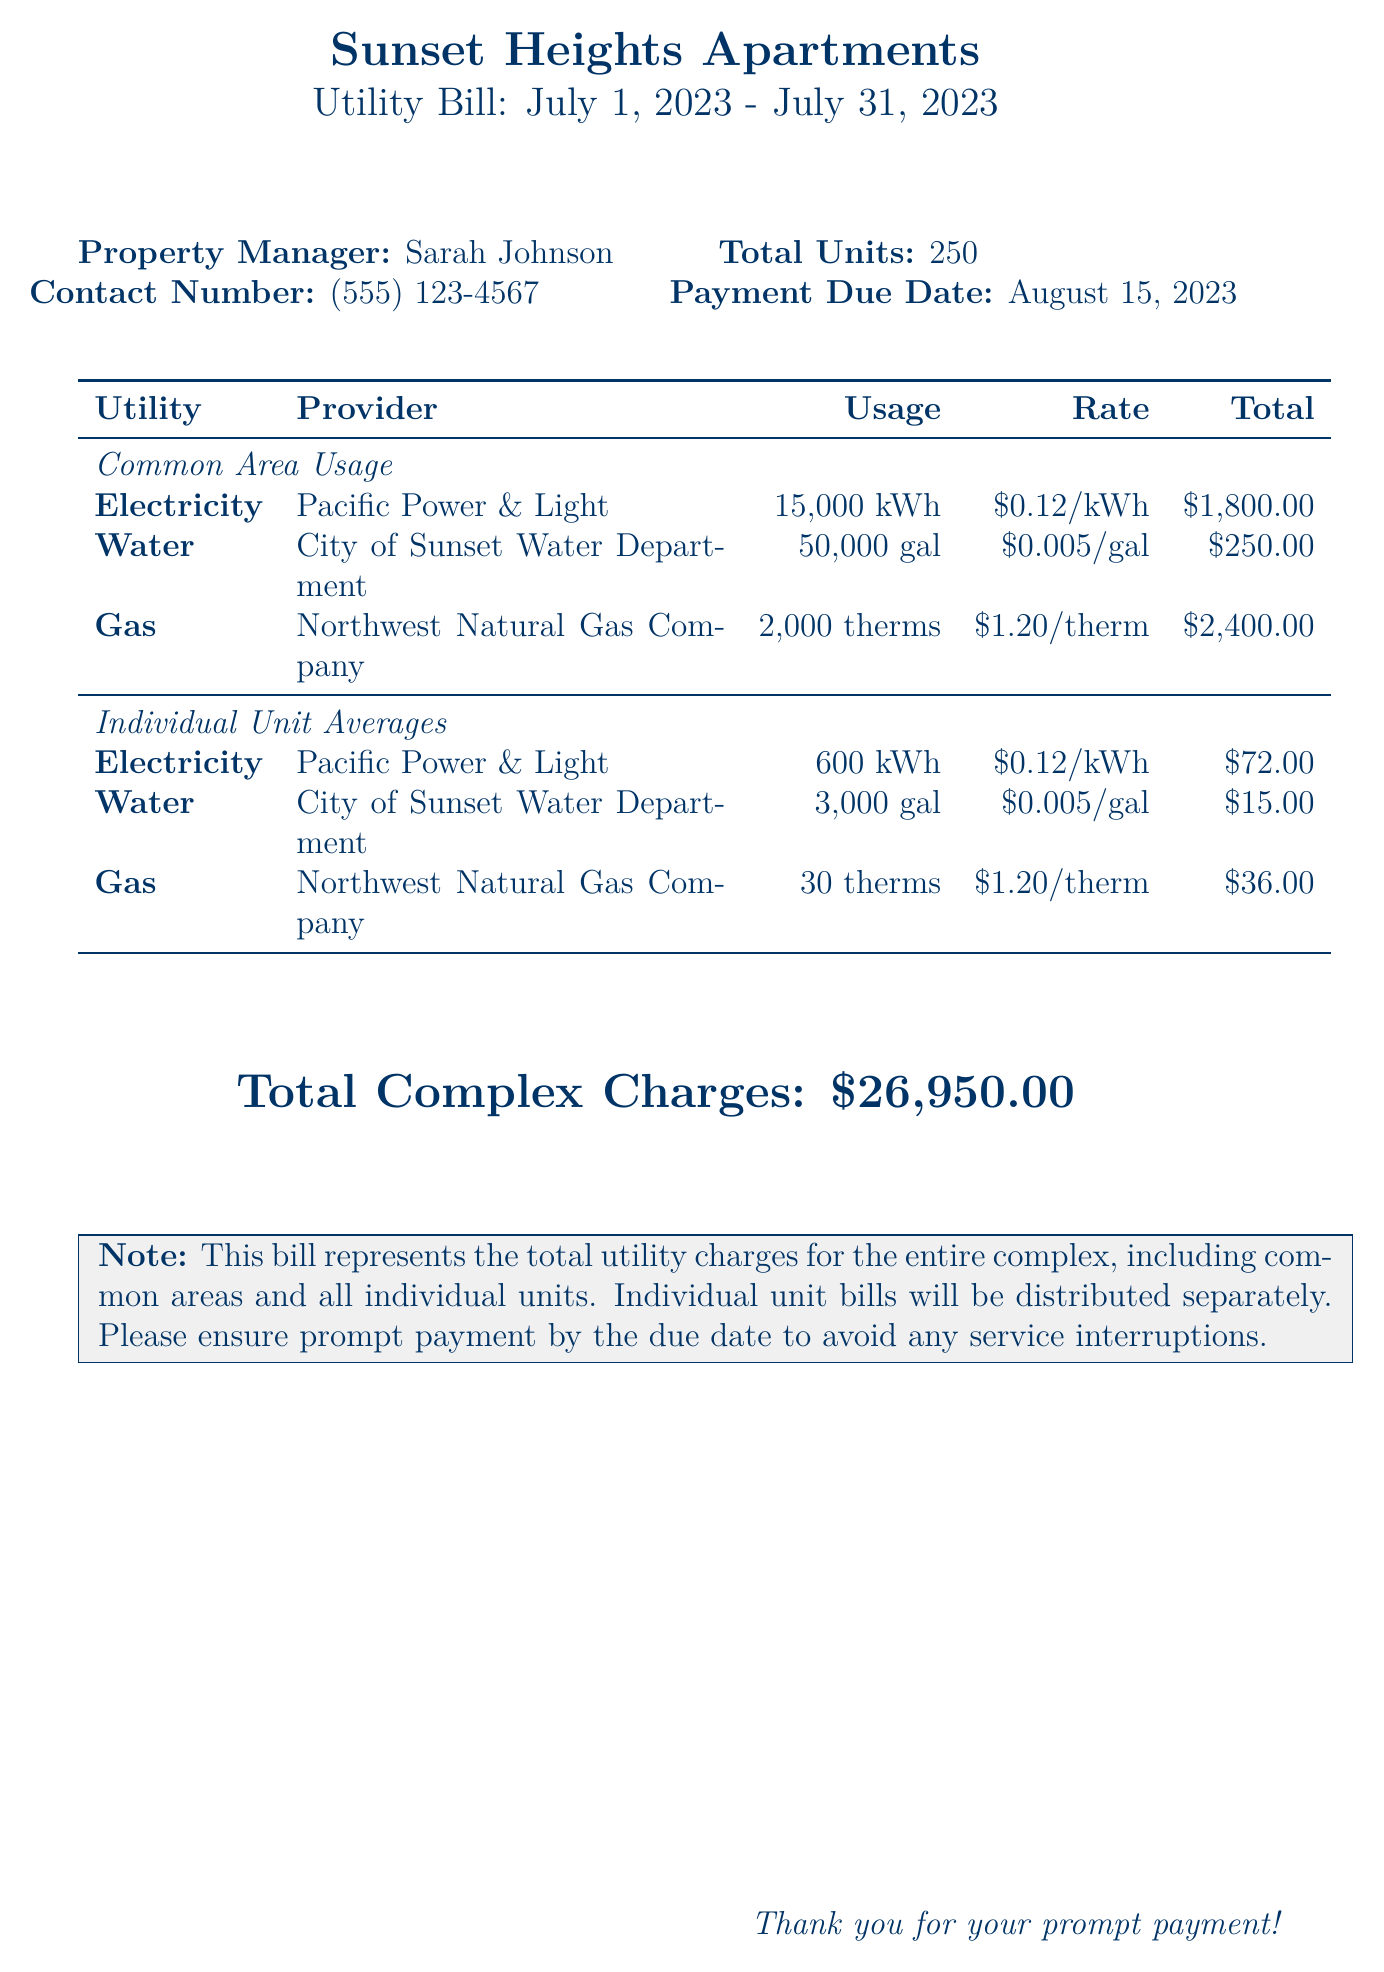what is the total number of units in the complex? The document states that there are a total of 250 units in the apartment complex.
Answer: 250 who is the property manager? The document lists Sarah Johnson as the property manager of the apartment complex.
Answer: Sarah Johnson what is the payment due date? The document specifies the payment due date as August 15, 2023.
Answer: August 15, 2023 how much is the total charge for electricity in the common areas? The total charge for electricity is provided in the common areas section and is $1,800.00.
Answer: $1,800.00 what is the total complex charge? The document indicates that the total charges for the entire complex amount to $26,950.00.
Answer: $26,950.00 what is the rate charged for water usage per gallon? The rate for water usage charged is noted in the document as $0.005 per gallon.
Answer: $0.005/gal how many therms of gas are used on average per individual unit? The text shows that each individual unit averages 30 therms of gas usage.
Answer: 30 therms what is the total water usage for the common areas? The common area water usage is listed as 50,000 gallons.
Answer: 50,000 gal which utility provider supplies gas for the complex? The document states that gas is supplied by Northwest Natural Gas Company.
Answer: Northwest Natural Gas Company 